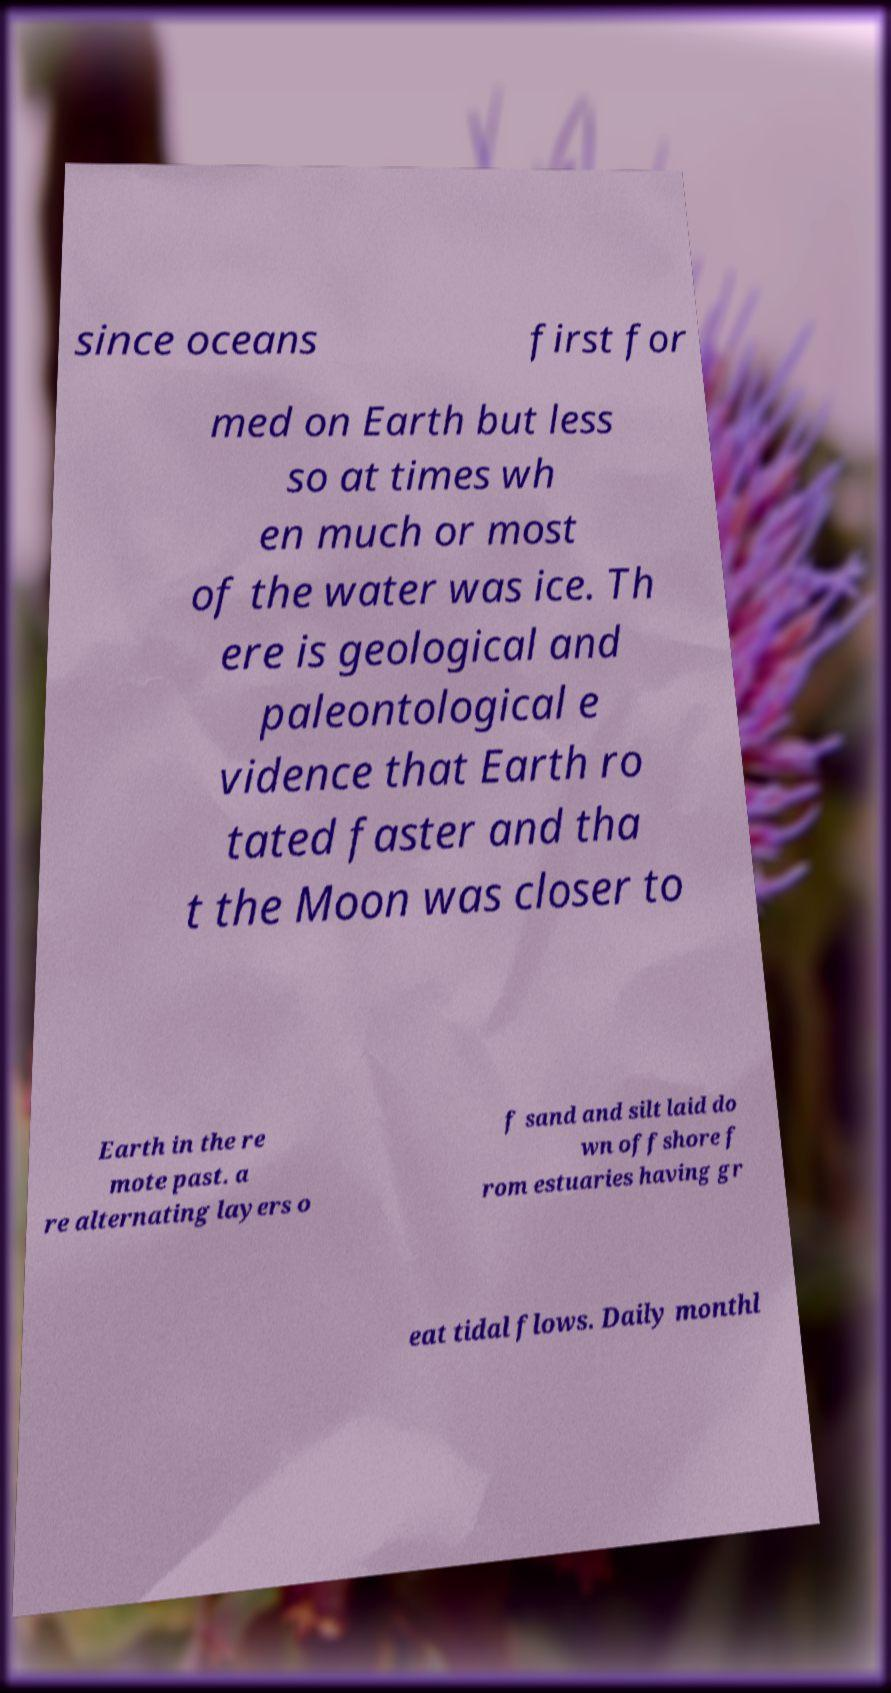For documentation purposes, I need the text within this image transcribed. Could you provide that? since oceans first for med on Earth but less so at times wh en much or most of the water was ice. Th ere is geological and paleontological e vidence that Earth ro tated faster and tha t the Moon was closer to Earth in the re mote past. a re alternating layers o f sand and silt laid do wn offshore f rom estuaries having gr eat tidal flows. Daily monthl 